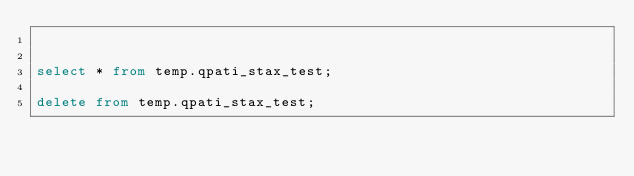<code> <loc_0><loc_0><loc_500><loc_500><_SQL_>

select * from temp.qpati_stax_test;

delete from temp.qpati_stax_test;</code> 